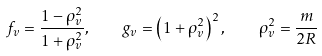Convert formula to latex. <formula><loc_0><loc_0><loc_500><loc_500>f _ { v } = \frac { 1 - \rho _ { v } ^ { 2 } } { 1 + \rho _ { v } ^ { 2 } } , \quad g _ { v } = \left ( 1 + \rho _ { v } ^ { 2 } \right ) ^ { 2 } , \quad \rho _ { v } ^ { 2 } = \frac { m } { 2 R }</formula> 